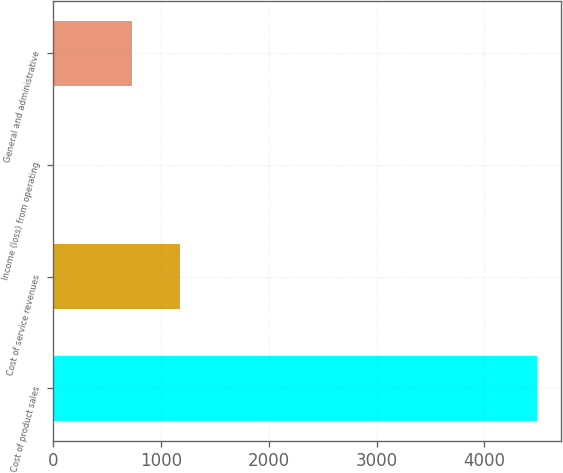Convert chart. <chart><loc_0><loc_0><loc_500><loc_500><bar_chart><fcel>Cost of product sales<fcel>Cost of service revenues<fcel>Income (loss) from operating<fcel>General and administrative<nl><fcel>4489<fcel>1173.8<fcel>11<fcel>726<nl></chart> 